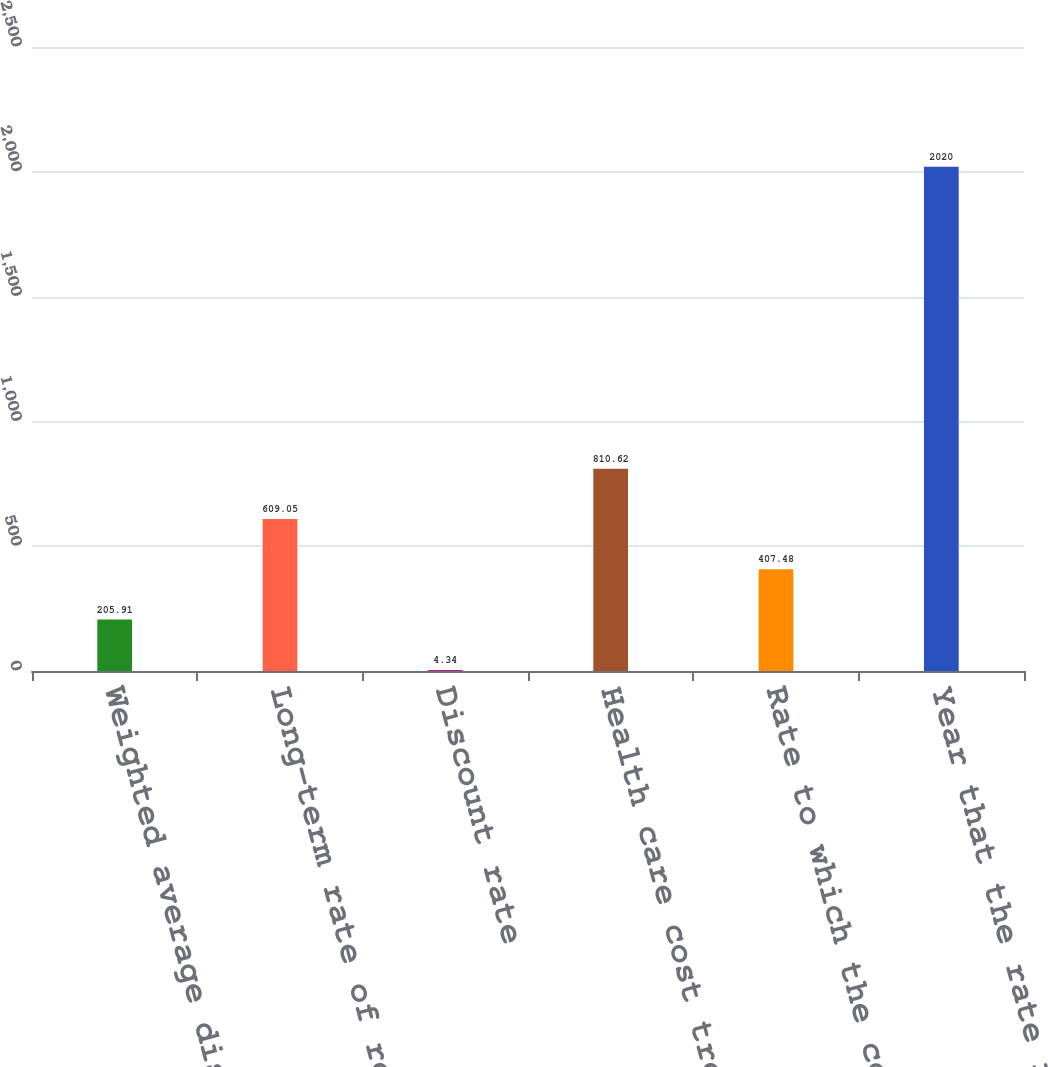<chart> <loc_0><loc_0><loc_500><loc_500><bar_chart><fcel>Weighted average discount rate<fcel>Long-term rate of return on<fcel>Discount rate<fcel>Health care cost trend rate<fcel>Rate to which the cost trend<fcel>Year that the rate reaches the<nl><fcel>205.91<fcel>609.05<fcel>4.34<fcel>810.62<fcel>407.48<fcel>2020<nl></chart> 